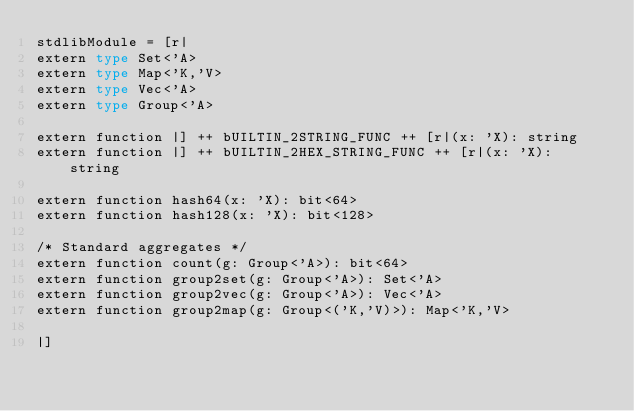Convert code to text. <code><loc_0><loc_0><loc_500><loc_500><_Haskell_>stdlibModule = [r| 
extern type Set<'A>
extern type Map<'K,'V>
extern type Vec<'A>
extern type Group<'A>

extern function |] ++ bUILTIN_2STRING_FUNC ++ [r|(x: 'X): string
extern function |] ++ bUILTIN_2HEX_STRING_FUNC ++ [r|(x: 'X): string

extern function hash64(x: 'X): bit<64>
extern function hash128(x: 'X): bit<128>

/* Standard aggregates */
extern function count(g: Group<'A>): bit<64>
extern function group2set(g: Group<'A>): Set<'A>
extern function group2vec(g: Group<'A>): Vec<'A>
extern function group2map(g: Group<('K,'V)>): Map<'K,'V>

|]
</code> 